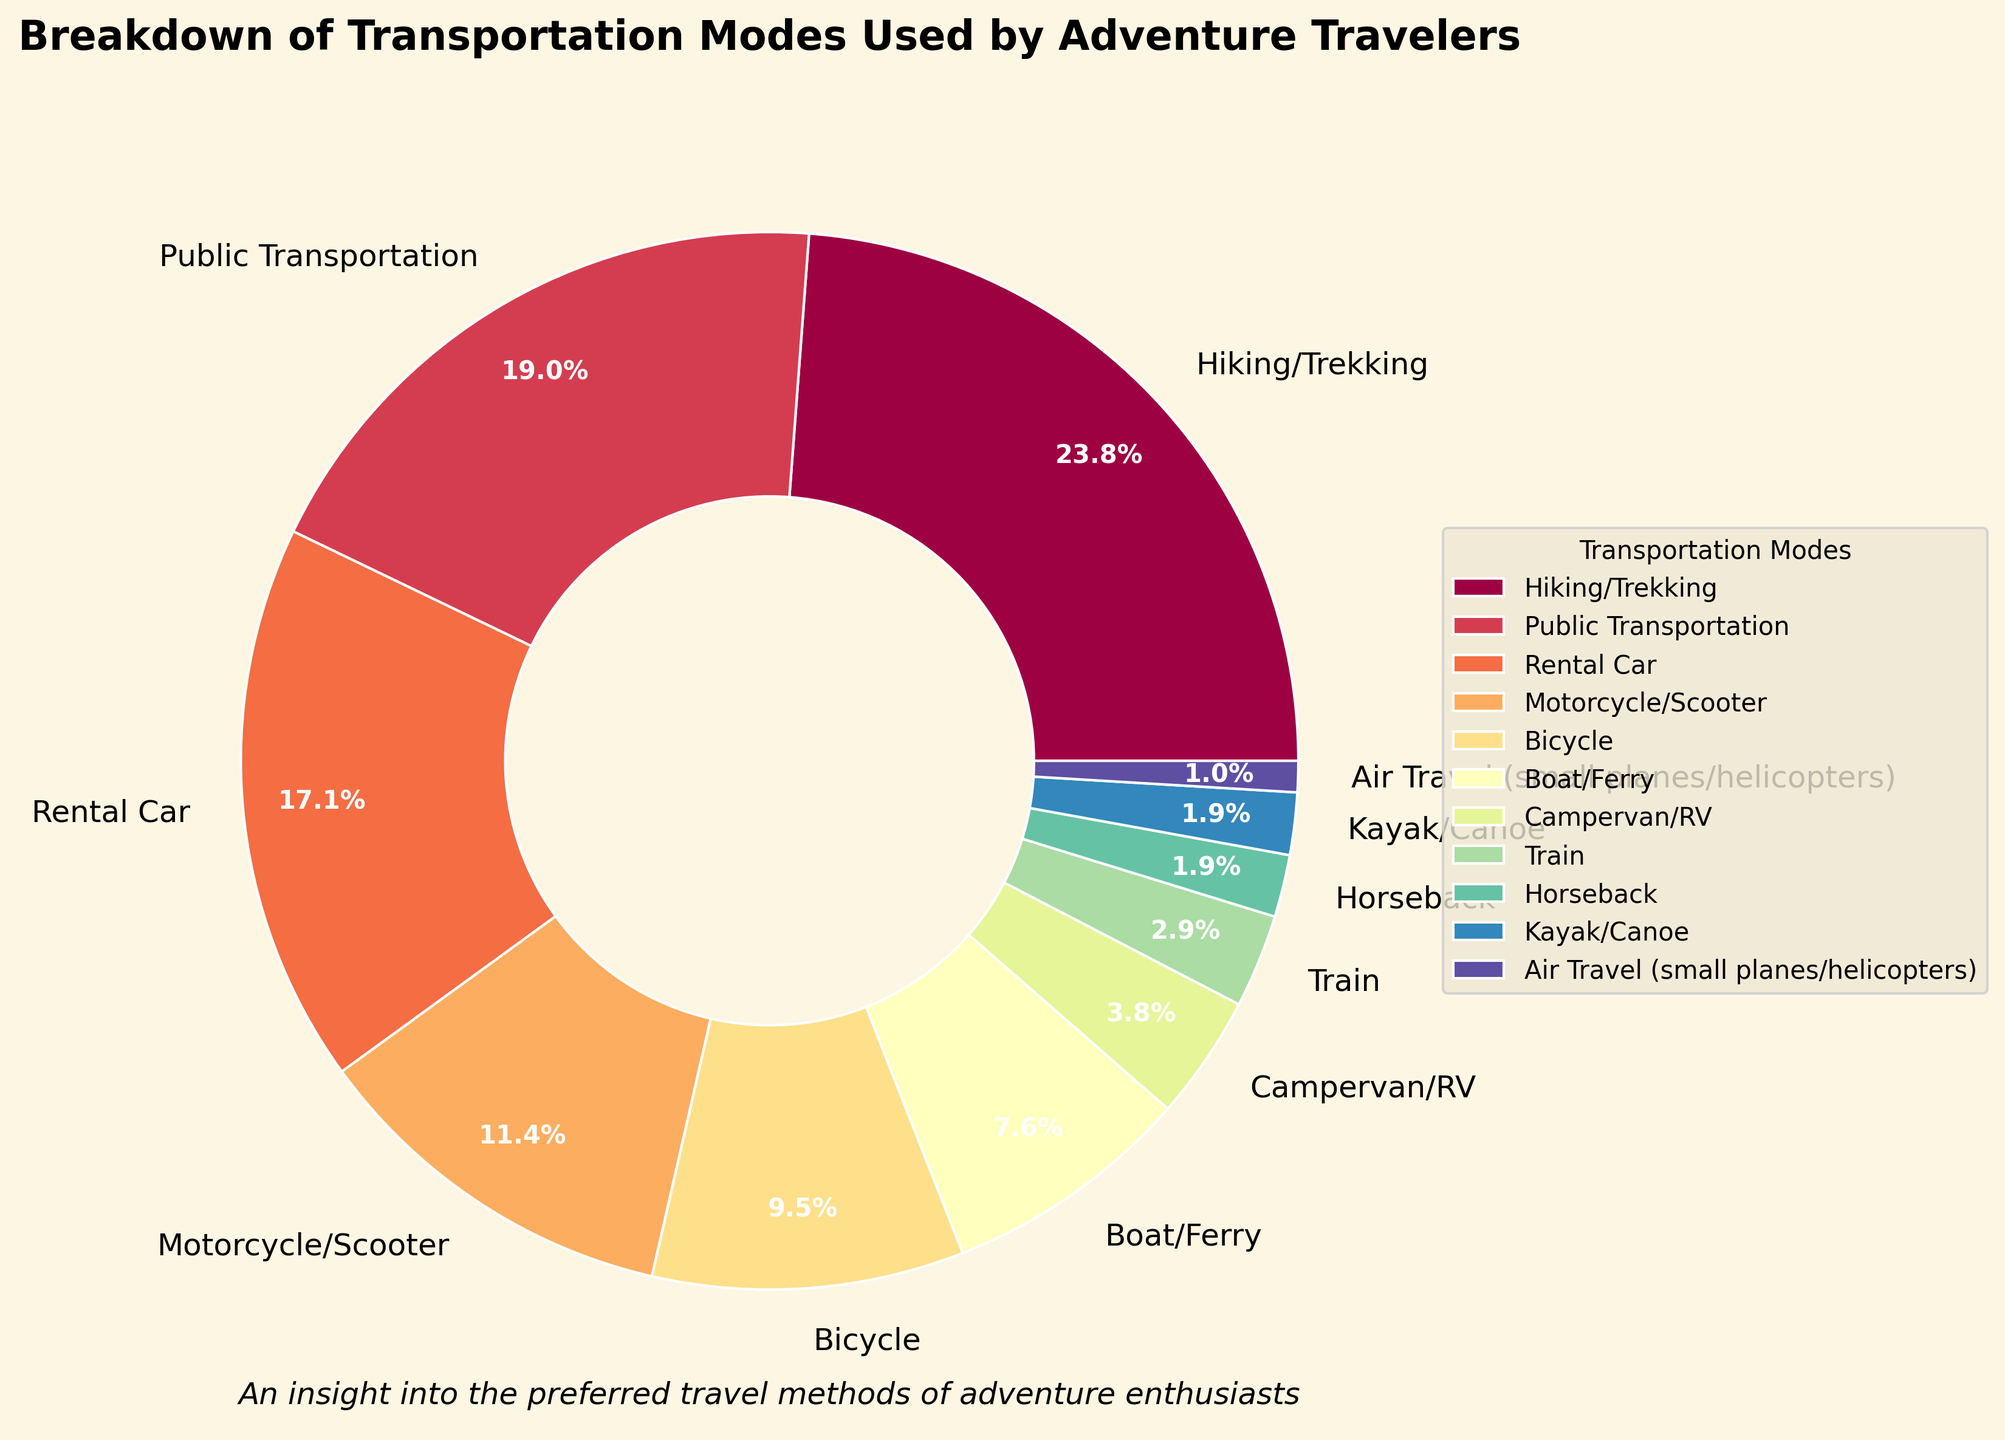what are the two most utilized transportation modes by adventure travelers? From the pie chart, the largest segments are for Hiking/Trekking (25%) and Public Transportation (20%), indicating these are the most utilized modes.
Answer: Hiking/Trekking and Public Transportation which transportation mode has a lower percentage, Motorcycle/Scooter or Bicycle? By comparing the chart segments, Motorcycle/Scooter has 12% and Bicycle has 10%, so Bicycle has a lower percentage.
Answer: Bicycle what is the total percentage of travelers who use Air Travel (small planes/helicopters), Kayak/Canoe, and Horseback combined? Adding the percentages: Air Travel (1%) + Kayak/Canoe (2%) + Horseback (2%) equals 5%.
Answer: 5% how much higher is the percentage of travelers using Rental Car compared to those using Campervan/RV? The Rental Car segment is 18% and the Campervan/RV segment is 4%. The difference is 18% - 4% = 14%.
Answer: 14% which transportation mode covers the largest segment of the pie chart? By observing the visual size of the segments, Hiking/Trekking has the largest segment at 25%.
Answer: Hiking/Trekking what is the ratio of travelers using Public Transportation to those using Bicycle? The segment for Public Transportation is 20% and for Bicycle is 10%. The ratio is 20%/10%, or simplified, 2:1.
Answer: 2:1 is the combined percentage of travelers using Train, Horseback, and Kayak/Canoe more than 5%? Summing the percentages: Train (3%) + Horseback (2%) + Kayak/Canoe (2%) equals 7%, which is more than 5%.
Answer: Yes which modes of transportation are least utilized by adventure travelers? The smallest segments are for Air Travel, Kayak/Canoe, and Horseback, each at 2% or less.
Answer: Air Travel, Kayak/Canoe, and Horseback is the percentage of travelers using Public Transportation greater than that of Motorcycle/Scooter and Boat/Ferry combined? Adding the percentages: Motorcycle/Scooter (12%) + Boat/Ferry (8%) equals 20%, which is equal to Public Transportation at 20%.
Answer: No 